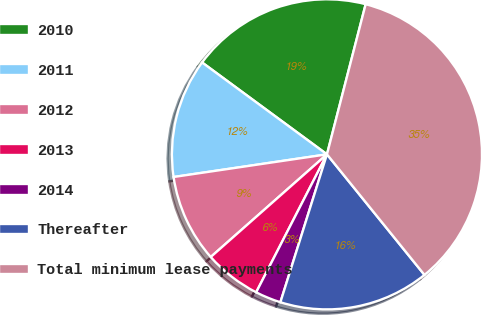Convert chart to OTSL. <chart><loc_0><loc_0><loc_500><loc_500><pie_chart><fcel>2010<fcel>2011<fcel>2012<fcel>2013<fcel>2014<fcel>Thereafter<fcel>Total minimum lease payments<nl><fcel>18.92%<fcel>12.43%<fcel>9.18%<fcel>5.94%<fcel>2.69%<fcel>15.68%<fcel>35.16%<nl></chart> 